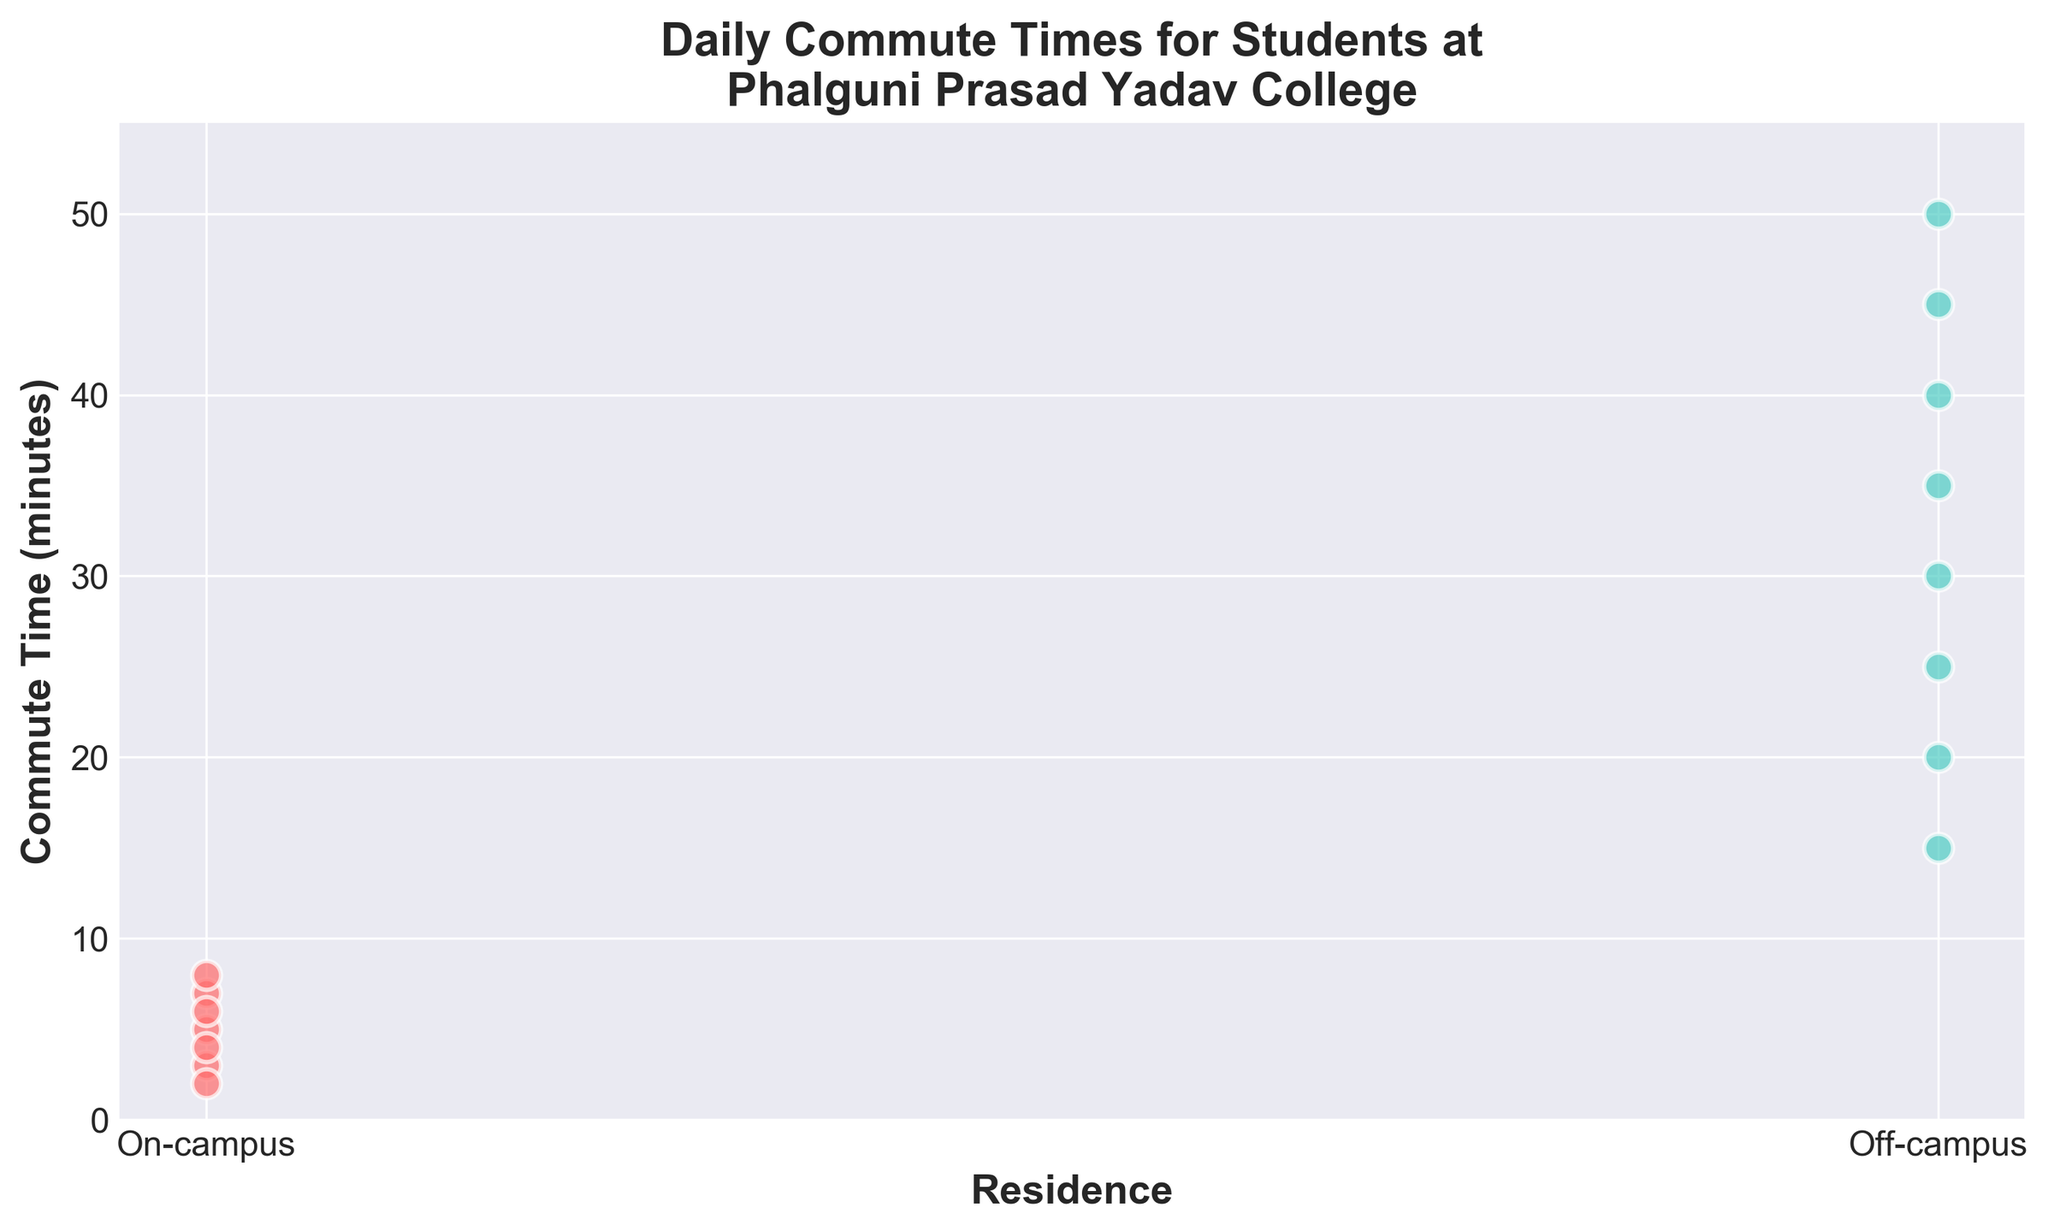What is the title of the figure? The title of the figure is displayed at the top and is meant to summarize what the plot is about. It says "Daily Commute Times for Students at Phalguni Prasad Yadav College."
Answer: Daily Commute Times for Students at Phalguni Prasad Yadav College How many students live on-campus? Each dot in the strip plot represents a student's commute time. Count the number of dots under "On-campus." There are seven dots in total.
Answer: 7 Which group has the longer average commute time? Compare the positions of the dots for both groups. The dots under "Off-campus" are generally much higher than those under "On-campus," indicating longer times.
Answer: Off-campus What is the range of commute times for on-campus students? Look at the lowest and highest points (dots) under "On-campus." The lowest is 2 minutes, and the highest is 8 minutes, so the range is 8 - 2.
Answer: 6 minutes What is the maximum commute time for off-campus students? The highest dot under "Off-campus" represents the maximum commute time. It corresponds to 50 minutes.
Answer: 50 minutes Is there overlap in commute times between on-campus and off-campus students? Check if any dots representing on-campus students align vertically with those representing off-campus students. There is no overlap as the maximum on-campus is 8 minutes and the minimum off-campus is 15 minutes.
Answer: No How many off-campus students have a commute time of over 30 minutes? Count the number of dots above the 30-minute mark under "Off-campus." There are four such dots (35, 40, 45, and 50).
Answer: 4 What is the median commute time for on-campus students? List the commute times for on-campus students in ascending order (2, 3, 4, 5, 6, 7, 8). The middle value in this ordered list is 5, as it is the fourth value.
Answer: 5 minutes What color represents on-campus students in the plot? The color of the dots under "On-campus" can be identified visually. They are represented in a reddish or pinkish color.
Answer: Reddish (or pinkish) How does the variance in commute times differ between on-campus and off-campus students? Visually compare the spread of the dots. "Off-campus" has dots scattered from 15 to 50 minutes, indicating high variance, while "On-campus" dots are closely packed from 2 to 8 minutes, showing low variance.
Answer: Off-campus has higher variance 